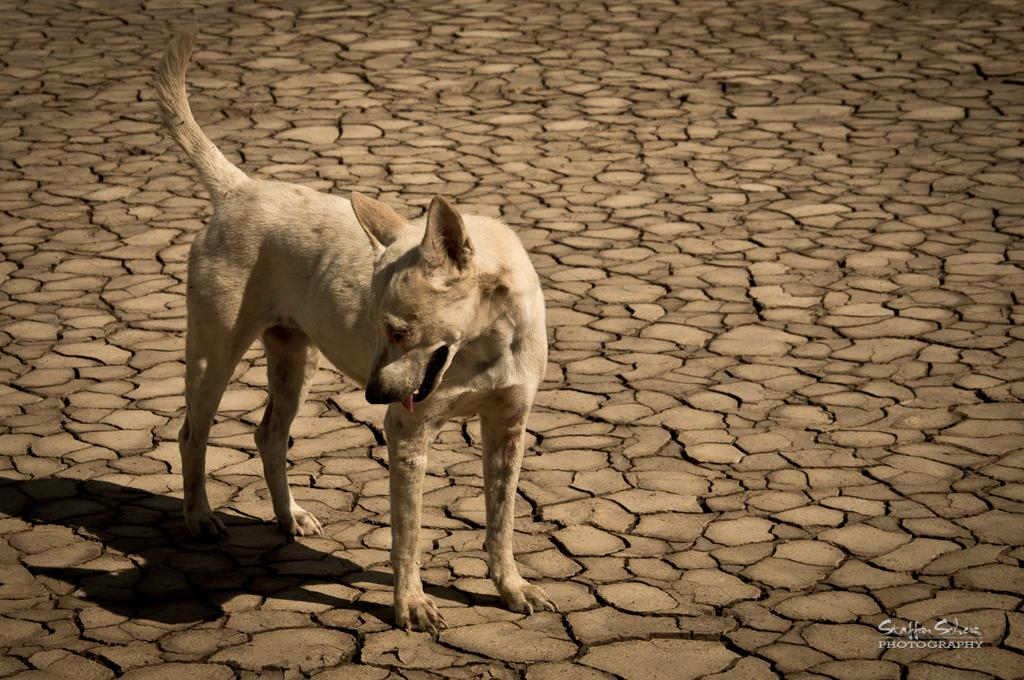What type of land is shown in the image? The image depicts a drought land. Can you describe any living creatures present in the image? Yes, there is a dog on the drought land. What type of hammer can be seen in the image? There is no hammer present in the image. What kind of waves can be observed in the background of the image? There are no waves visible in the image, as it depicts a drought land. 